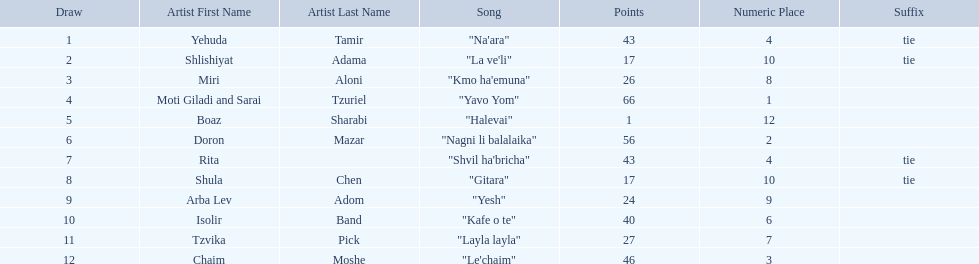Who are all of the artists? Yehuda Tamir, Shlishiyat Adama, Miri Aloni, Moti Giladi and Sarai Tzuriel, Boaz Sharabi, Doron Mazar, Rita, Shula Chen, Arba Lev Adom, Isolir Band, Tzvika Pick, Chaim Moshe. Could you parse the entire table as a dict? {'header': ['Draw', 'Artist First Name', 'Artist Last Name', 'Song', 'Points', 'Numeric Place', 'Suffix'], 'rows': [['1', 'Yehuda', 'Tamir', '"Na\'ara"', '43', '4', 'tie'], ['2', 'Shlishiyat', 'Adama', '"La ve\'li"', '17', '10', 'tie'], ['3', 'Miri', 'Aloni', '"Kmo ha\'emuna"', '26', '8', ''], ['4', 'Moti Giladi and Sarai', 'Tzuriel', '"Yavo Yom"', '66', '1', ''], ['5', 'Boaz', 'Sharabi', '"Halevai"', '1', '12', ''], ['6', 'Doron', 'Mazar', '"Nagni li balalaika"', '56', '2', ''], ['7', 'Rita', '', '"Shvil ha\'bricha"', '43', '4', 'tie'], ['8', 'Shula', 'Chen', '"Gitara"', '17', '10', 'tie'], ['9', 'Arba Lev', 'Adom', '"Yesh"', '24', '9', ''], ['10', 'Isolir', 'Band', '"Kafe o te"', '40', '6', ''], ['11', 'Tzvika', 'Pick', '"Layla layla"', '27', '7', ''], ['12', 'Chaim', 'Moshe', '"Le\'chaim"', '46', '3', '']]} How many points did each score? 43, 17, 26, 66, 1, 56, 43, 17, 24, 40, 27, 46. And which artist had the least amount of points? Boaz Sharabi. 